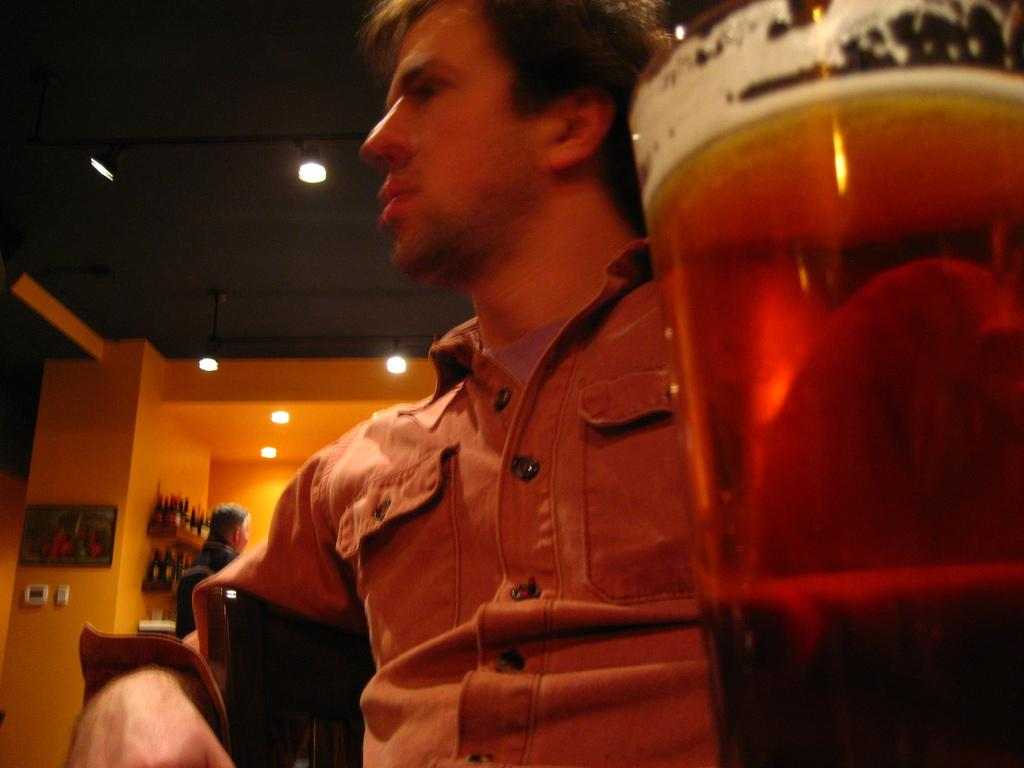What is the person in the image doing? The person is sitting in a chair. What can be seen in the right corner of the image? There is a glass of wine in the right corner of the image. What other objects can be seen in the background of the image? There are other objects present in the background of the image, but their specific details are not mentioned in the provided facts. What type of cow can be seen tied to a string in the image? There is no cow or string present in the image. 